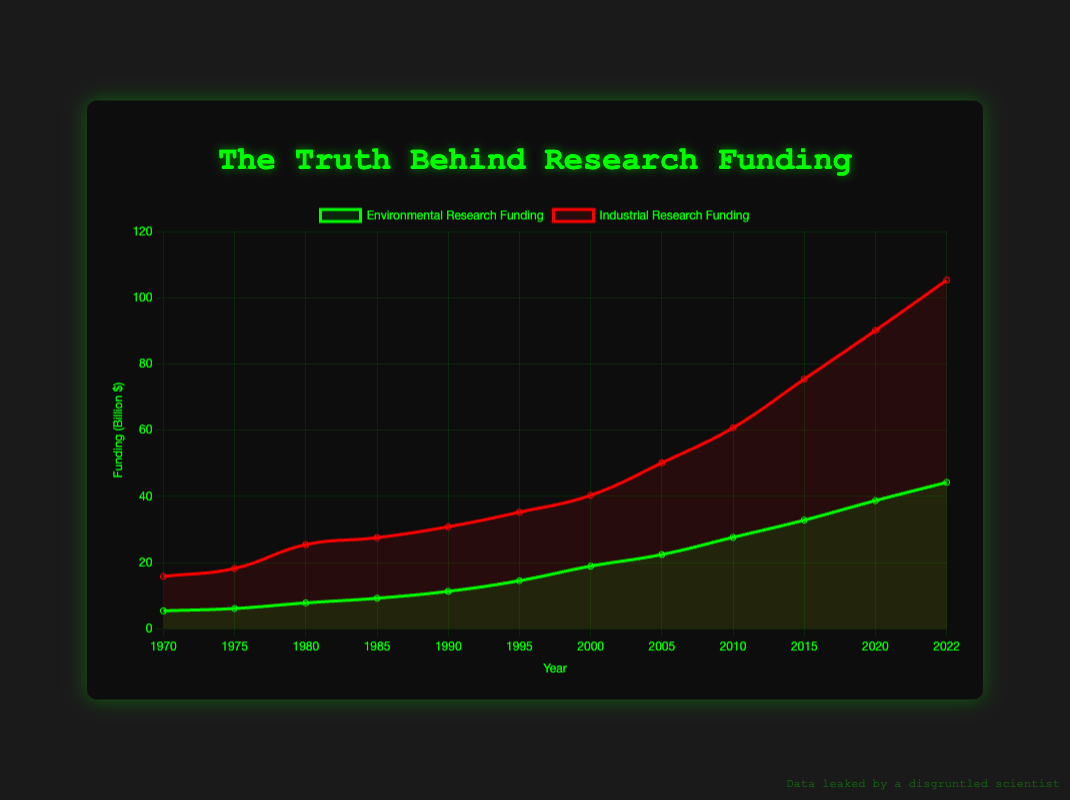What is the total funding for environmental research in 2020 and 2022? The funding for environmental research in 2020 is 38.7 billion and in 2022 it is 44.2 billion. Summing these values, 38.7 + 44.2 = 82.9 billion.
Answer: 82.9 billion How does the rate of increase in industrial research funding from 2010 to 2015 compare to that from 2015 to 2020? The increase from 2010 to 2015 is 75.4 - 60.7 = 14.7 billion. The increase from 2015 to 2020 is 90.1 - 75.4 = 14.7 billion. Both periods experienced the same increase.
Answer: The same Which year had the highest discrepancy between environmental research funding and industrial research funding? To find the greatest discrepancy, subtract environmental research funding from industrial research funding for each year and compare. The highest discrepancy is in 2022 with 105.3 - 44.2 = 61.1 billion.
Answer: 2022 Between 1980 and 1990, which type of research funding grew more? Calculate the increase for environmental research: 11.3 - 7.8 = 3.5 billion. For industrial research: 30.8 - 25.4 = 5.4 billion. Industrial research funding grew more.
Answer: Industrial research What is the average environmental research funding between 1970 and 1990? Sum the environmental research funding values for the years 1970, 1975, 1980, 1985, and 1990: 5.4 + 6.1 + 7.8 + 9.2 + 11.3 = 39.8 billion. There are 5 years, so the average is 39.8 / 5 = 7.96 billion.
Answer: 7.96 billion Which dataset has a steeper slope between 2005 and 2015 based on the visual lines? Compare the steepness of the lines. Environmental research funding rises from 22.4 to 32.8, a change of 10.4 billion. Industrial research funding rises from 50.1 to 75.4, a change of 25.3 billion. Therefore, industrial research funding has a steeper slope.
Answer: Industrial research In what year did environmental research funding surpass 20 billion? By examining the plotted points, environmental research funding surpasses 20 billion in 2005.
Answer: 2005 